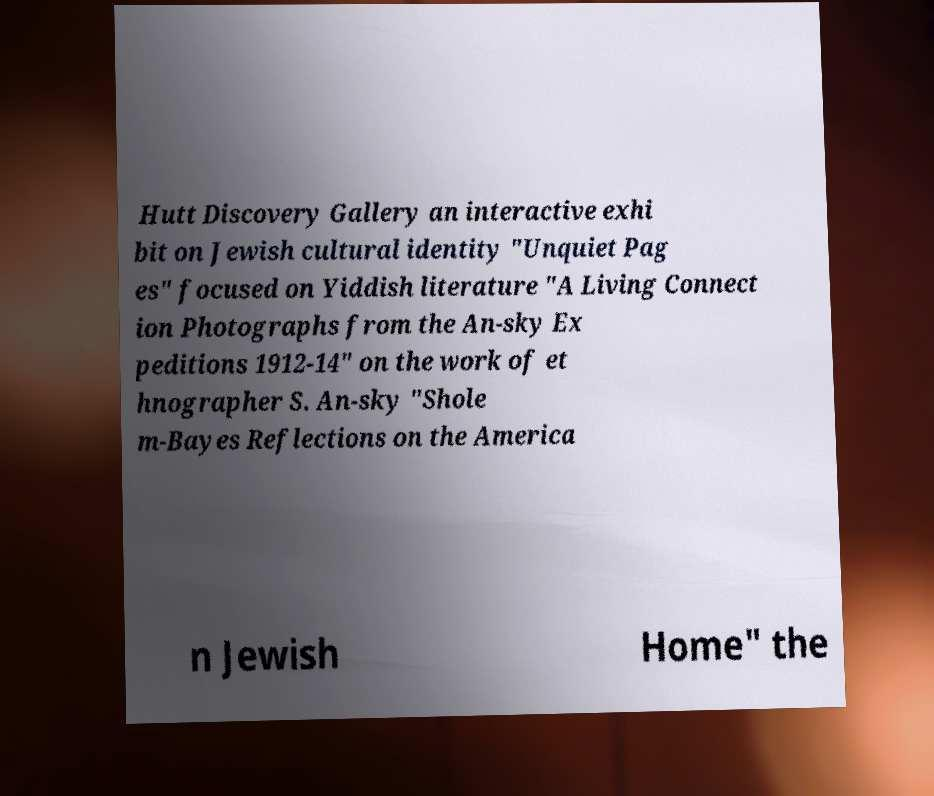For documentation purposes, I need the text within this image transcribed. Could you provide that? Hutt Discovery Gallery an interactive exhi bit on Jewish cultural identity "Unquiet Pag es" focused on Yiddish literature "A Living Connect ion Photographs from the An-sky Ex peditions 1912-14" on the work of et hnographer S. An-sky "Shole m-Bayes Reflections on the America n Jewish Home" the 